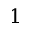Convert formula to latex. <formula><loc_0><loc_0><loc_500><loc_500>1</formula> 